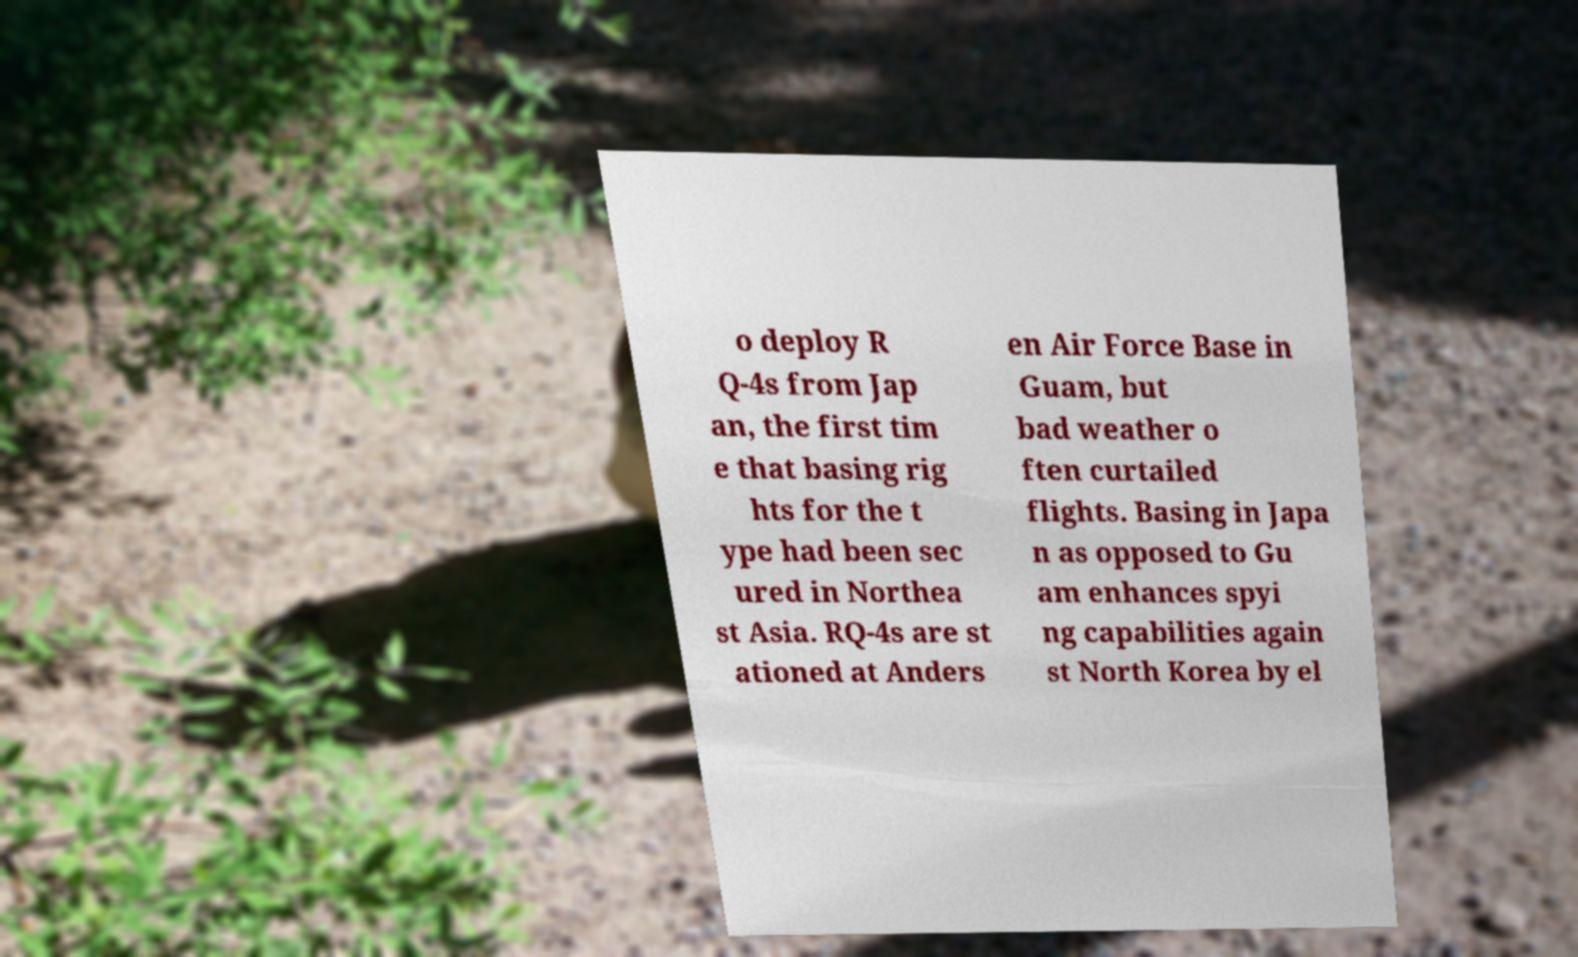Can you read and provide the text displayed in the image?This photo seems to have some interesting text. Can you extract and type it out for me? o deploy R Q-4s from Jap an, the first tim e that basing rig hts for the t ype had been sec ured in Northea st Asia. RQ-4s are st ationed at Anders en Air Force Base in Guam, but bad weather o ften curtailed flights. Basing in Japa n as opposed to Gu am enhances spyi ng capabilities again st North Korea by el 